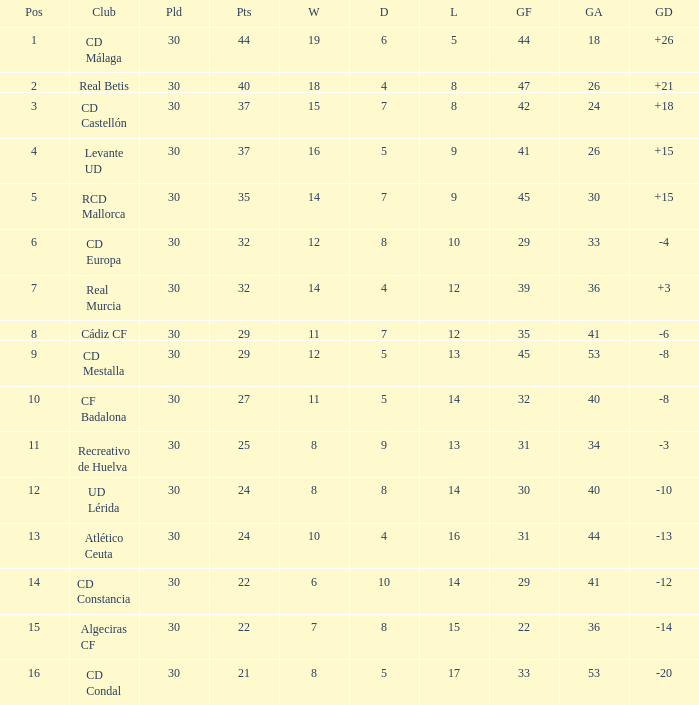Can you give me this table as a dict? {'header': ['Pos', 'Club', 'Pld', 'Pts', 'W', 'D', 'L', 'GF', 'GA', 'GD'], 'rows': [['1', 'CD Málaga', '30', '44', '19', '6', '5', '44', '18', '+26'], ['2', 'Real Betis', '30', '40', '18', '4', '8', '47', '26', '+21'], ['3', 'CD Castellón', '30', '37', '15', '7', '8', '42', '24', '+18'], ['4', 'Levante UD', '30', '37', '16', '5', '9', '41', '26', '+15'], ['5', 'RCD Mallorca', '30', '35', '14', '7', '9', '45', '30', '+15'], ['6', 'CD Europa', '30', '32', '12', '8', '10', '29', '33', '-4'], ['7', 'Real Murcia', '30', '32', '14', '4', '12', '39', '36', '+3'], ['8', 'Cádiz CF', '30', '29', '11', '7', '12', '35', '41', '-6'], ['9', 'CD Mestalla', '30', '29', '12', '5', '13', '45', '53', '-8'], ['10', 'CF Badalona', '30', '27', '11', '5', '14', '32', '40', '-8'], ['11', 'Recreativo de Huelva', '30', '25', '8', '9', '13', '31', '34', '-3'], ['12', 'UD Lérida', '30', '24', '8', '8', '14', '30', '40', '-10'], ['13', 'Atlético Ceuta', '30', '24', '10', '4', '16', '31', '44', '-13'], ['14', 'CD Constancia', '30', '22', '6', '10', '14', '29', '41', '-12'], ['15', 'Algeciras CF', '30', '22', '7', '8', '15', '22', '36', '-14'], ['16', 'CD Condal', '30', '21', '8', '5', '17', '33', '53', '-20']]} What is the losses when the goal difference is larger than 26? None. 